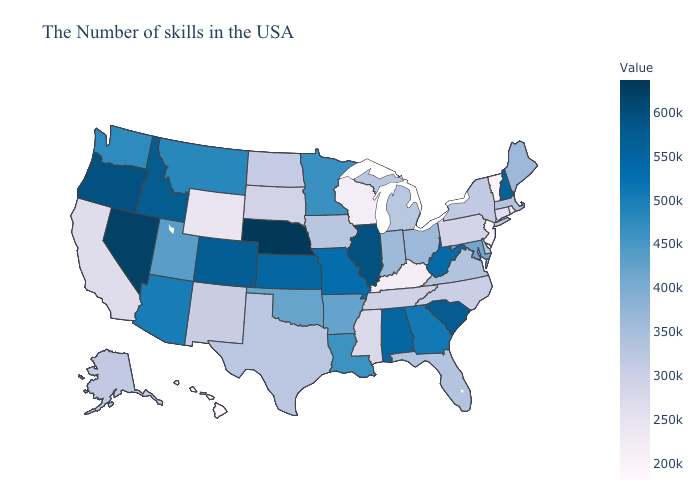Does Hawaii have a higher value than Delaware?
Give a very brief answer. No. Does Nevada have the highest value in the USA?
Answer briefly. No. Does Nebraska have the highest value in the USA?
Answer briefly. Yes. Which states have the lowest value in the Northeast?
Keep it brief. New Jersey. Among the states that border Maryland , does Pennsylvania have the lowest value?
Write a very short answer. Yes. Which states hav the highest value in the MidWest?
Answer briefly. Nebraska. Does New Hampshire have the highest value in the Northeast?
Give a very brief answer. Yes. 